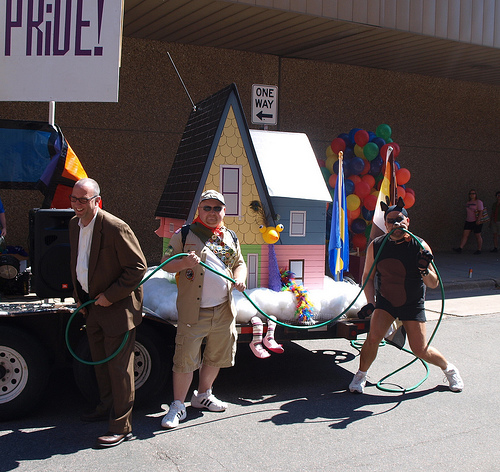<image>
Can you confirm if the balloon is in front of the house? No. The balloon is not in front of the house. The spatial positioning shows a different relationship between these objects. 